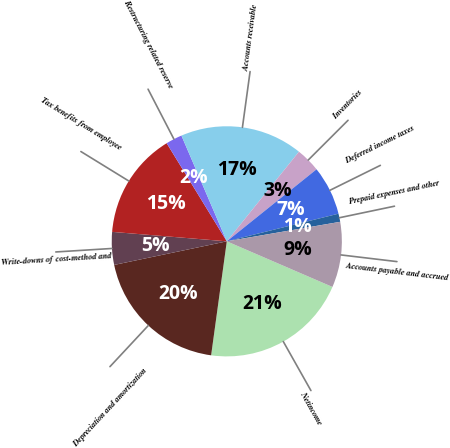<chart> <loc_0><loc_0><loc_500><loc_500><pie_chart><fcel>Netincome<fcel>Depreciation and amortization<fcel>Write-downs of cost-method and<fcel>Tax benefits from employee<fcel>Restructuring related reserve<fcel>Accounts receivable<fcel>Inventories<fcel>Deferred income taxes<fcel>Prepaid expenses and other<fcel>Accounts payable and accrued<nl><fcel>20.69%<fcel>19.54%<fcel>4.6%<fcel>14.94%<fcel>2.3%<fcel>17.24%<fcel>3.45%<fcel>6.9%<fcel>1.15%<fcel>9.2%<nl></chart> 